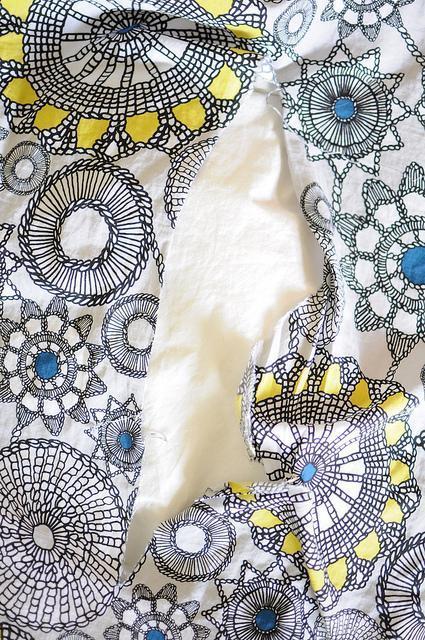How many sheep are sticking their head through the fence?
Give a very brief answer. 0. 